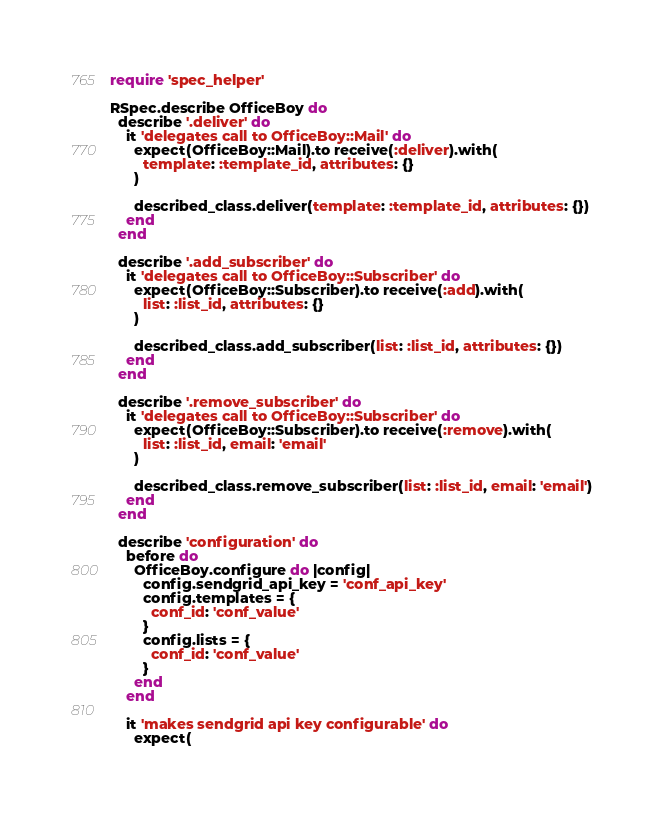<code> <loc_0><loc_0><loc_500><loc_500><_Ruby_>require 'spec_helper'

RSpec.describe OfficeBoy do
  describe '.deliver' do
    it 'delegates call to OfficeBoy::Mail' do
      expect(OfficeBoy::Mail).to receive(:deliver).with(
        template: :template_id, attributes: {}
      )

      described_class.deliver(template: :template_id, attributes: {})
    end
  end

  describe '.add_subscriber' do
    it 'delegates call to OfficeBoy::Subscriber' do
      expect(OfficeBoy::Subscriber).to receive(:add).with(
        list: :list_id, attributes: {}
      )

      described_class.add_subscriber(list: :list_id, attributes: {})
    end
  end

  describe '.remove_subscriber' do
    it 'delegates call to OfficeBoy::Subscriber' do
      expect(OfficeBoy::Subscriber).to receive(:remove).with(
        list: :list_id, email: 'email'
      )

      described_class.remove_subscriber(list: :list_id, email: 'email')
    end
  end

  describe 'configuration' do
    before do
      OfficeBoy.configure do |config|
        config.sendgrid_api_key = 'conf_api_key'
        config.templates = {
          conf_id: 'conf_value'
        }
        config.lists = {
          conf_id: 'conf_value'
        }
      end
    end

    it 'makes sendgrid api key configurable' do
      expect(</code> 